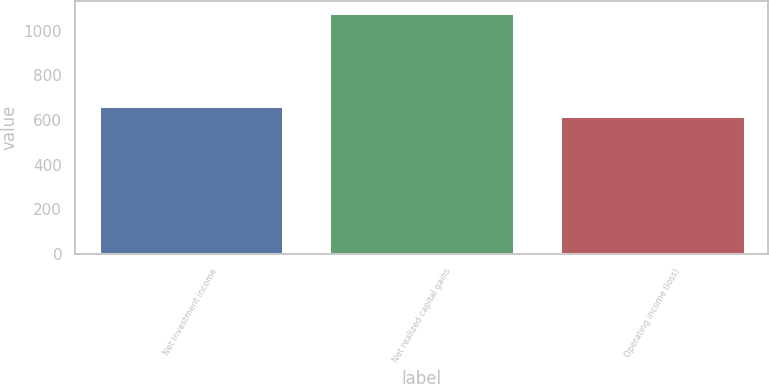<chart> <loc_0><loc_0><loc_500><loc_500><bar_chart><fcel>Net investment income<fcel>Net realized capital gains<fcel>Operating income (loss)<nl><fcel>664.2<fcel>1080<fcel>618<nl></chart> 